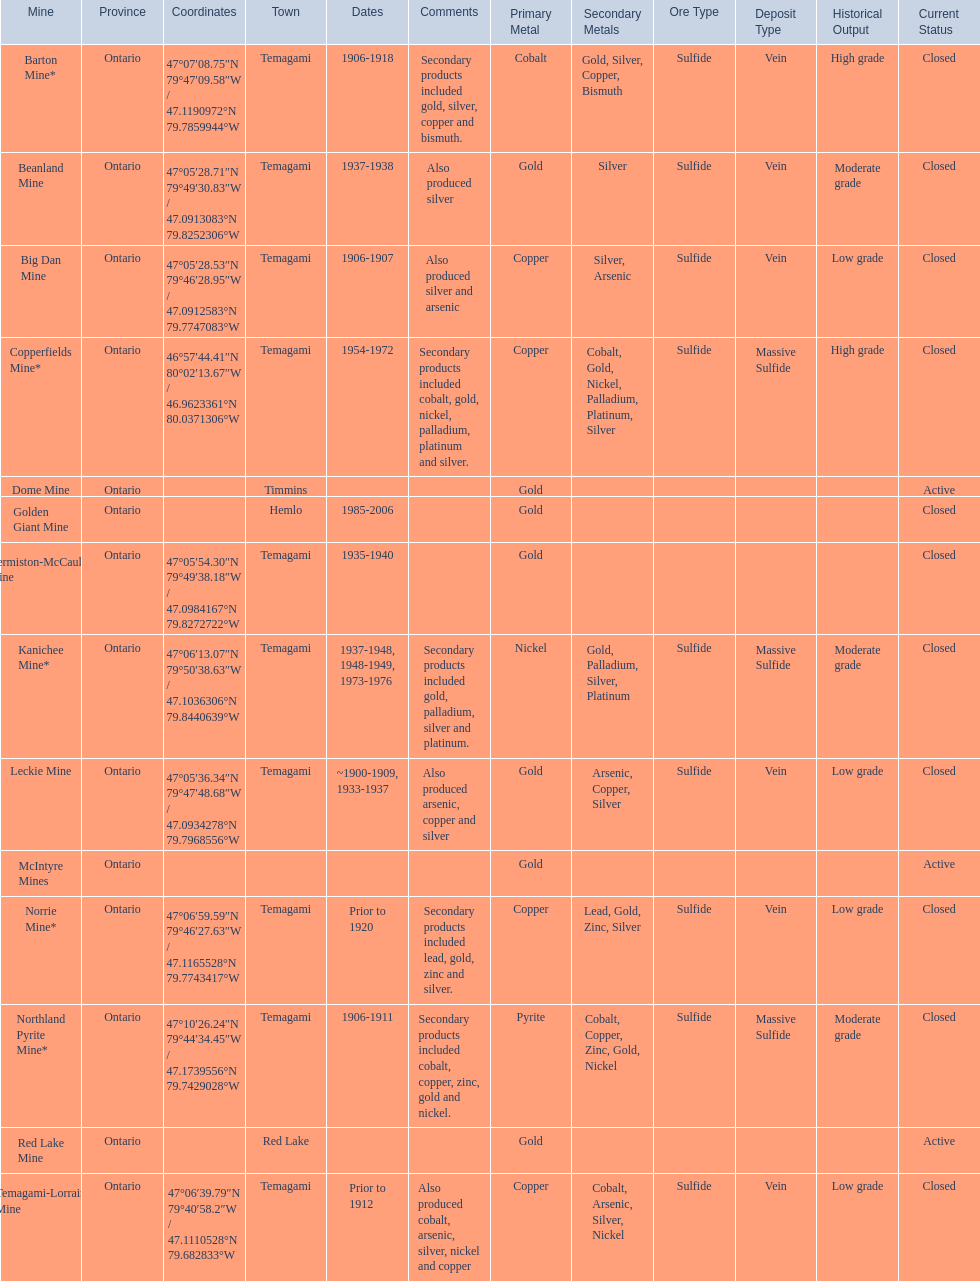What province is the town of temagami? Ontario. 